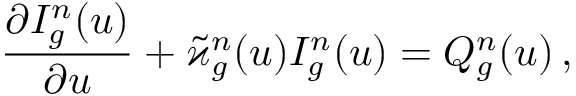<formula> <loc_0><loc_0><loc_500><loc_500>\frac { \partial I _ { g } ^ { n } ( u ) } { \partial u } + \tilde { \varkappa } _ { g } ^ { n } ( u ) I _ { g } ^ { n } ( u ) = { Q } _ { g } ^ { n } ( u ) \, ,</formula> 